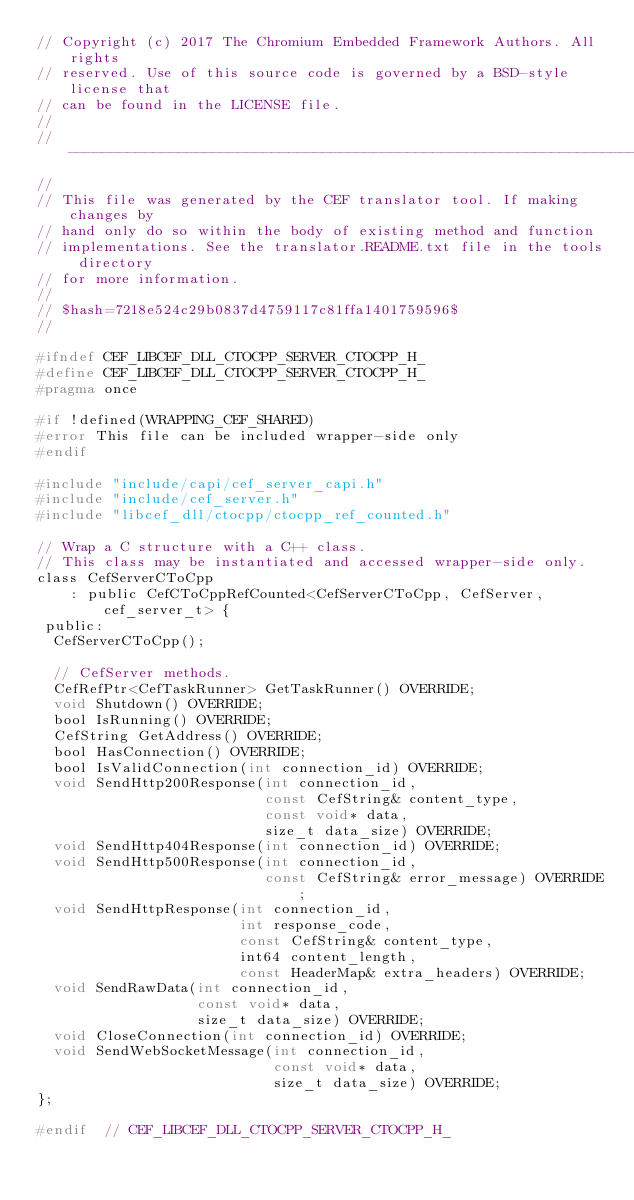Convert code to text. <code><loc_0><loc_0><loc_500><loc_500><_C_>// Copyright (c) 2017 The Chromium Embedded Framework Authors. All rights
// reserved. Use of this source code is governed by a BSD-style license that
// can be found in the LICENSE file.
//
// ---------------------------------------------------------------------------
//
// This file was generated by the CEF translator tool. If making changes by
// hand only do so within the body of existing method and function
// implementations. See the translator.README.txt file in the tools directory
// for more information.
//
// $hash=7218e524c29b0837d4759117c81ffa1401759596$
//

#ifndef CEF_LIBCEF_DLL_CTOCPP_SERVER_CTOCPP_H_
#define CEF_LIBCEF_DLL_CTOCPP_SERVER_CTOCPP_H_
#pragma once

#if !defined(WRAPPING_CEF_SHARED)
#error This file can be included wrapper-side only
#endif

#include "include/capi/cef_server_capi.h"
#include "include/cef_server.h"
#include "libcef_dll/ctocpp/ctocpp_ref_counted.h"

// Wrap a C structure with a C++ class.
// This class may be instantiated and accessed wrapper-side only.
class CefServerCToCpp
    : public CefCToCppRefCounted<CefServerCToCpp, CefServer, cef_server_t> {
 public:
  CefServerCToCpp();

  // CefServer methods.
  CefRefPtr<CefTaskRunner> GetTaskRunner() OVERRIDE;
  void Shutdown() OVERRIDE;
  bool IsRunning() OVERRIDE;
  CefString GetAddress() OVERRIDE;
  bool HasConnection() OVERRIDE;
  bool IsValidConnection(int connection_id) OVERRIDE;
  void SendHttp200Response(int connection_id,
                           const CefString& content_type,
                           const void* data,
                           size_t data_size) OVERRIDE;
  void SendHttp404Response(int connection_id) OVERRIDE;
  void SendHttp500Response(int connection_id,
                           const CefString& error_message) OVERRIDE;
  void SendHttpResponse(int connection_id,
                        int response_code,
                        const CefString& content_type,
                        int64 content_length,
                        const HeaderMap& extra_headers) OVERRIDE;
  void SendRawData(int connection_id,
                   const void* data,
                   size_t data_size) OVERRIDE;
  void CloseConnection(int connection_id) OVERRIDE;
  void SendWebSocketMessage(int connection_id,
                            const void* data,
                            size_t data_size) OVERRIDE;
};

#endif  // CEF_LIBCEF_DLL_CTOCPP_SERVER_CTOCPP_H_
</code> 